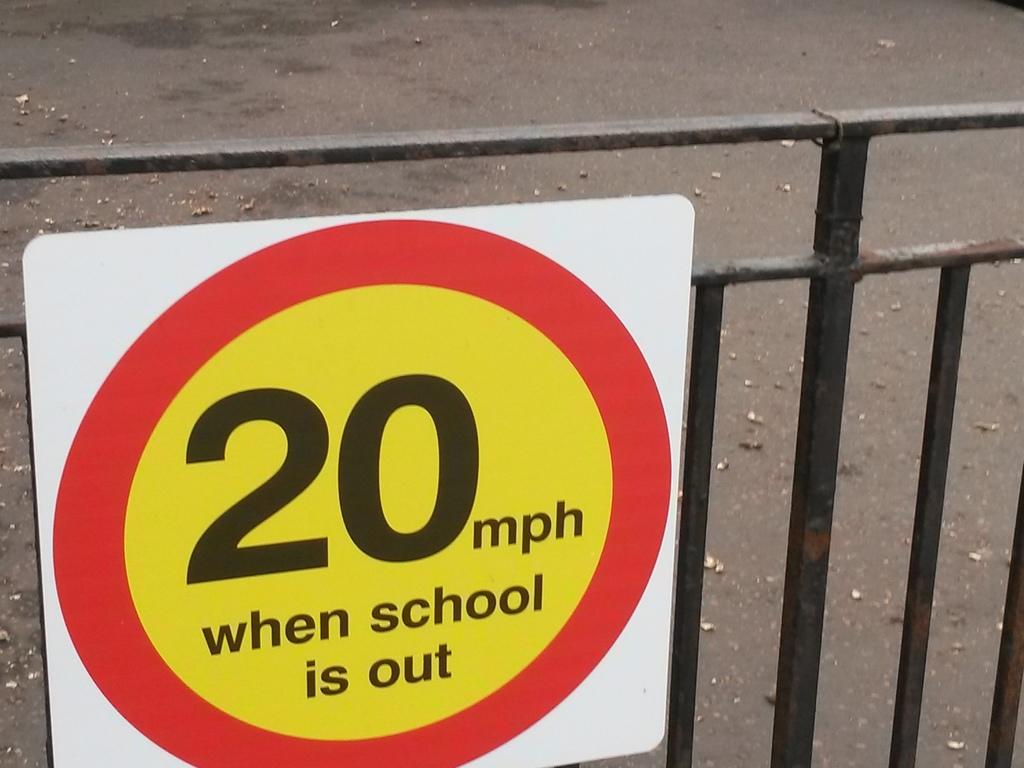When is the speed limit for?
Your response must be concise. When school is out. 